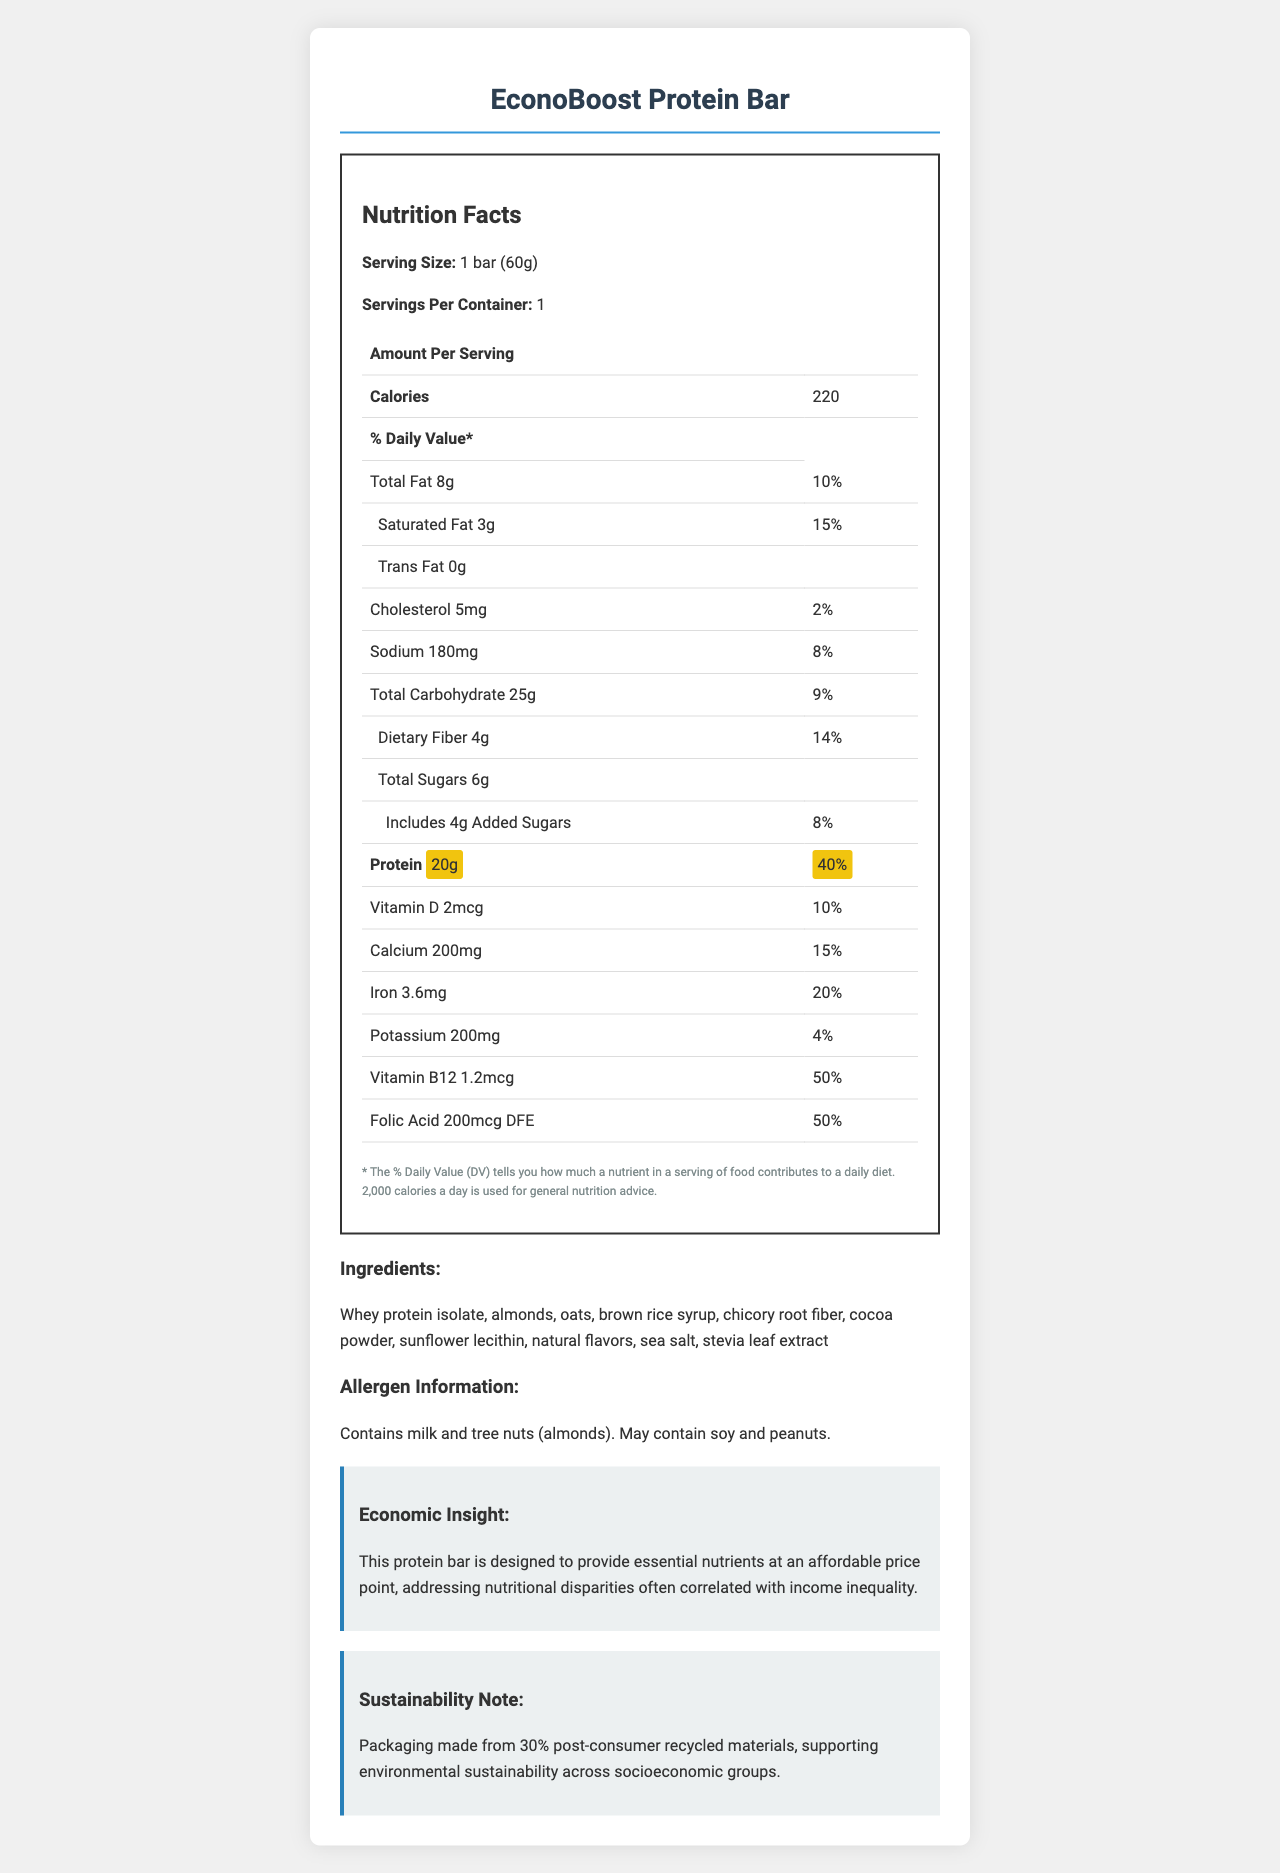what is the serving size? The serving size is explicitly mentioned under the Nutrition Facts section.
Answer: 1 bar (60g) How much protein does one serving of the EconoBoost Protein Bar contain? The amount of protein is highlighted and mentioned as 20g in the Nutrition Facts table.
Answer: 20g What percentage of the daily value of protein does the EconoBoost Protein Bar provide? Under the Nutrition Facts, the protein content is indicated as 20g, which corresponds to 40% of the daily value.
Answer: 40% Which vitamins and minerals are highlighted in the nutrition label? The vitamins and minerals, along with their amounts and daily values, are listed in the Nutrition Facts table.
Answer: Vitamin D, Calcium, Iron, Potassium, Vitamin B12, Folic Acid How much calcium is in one serving of the EconoBoost Protein Bar? In the Nutrition Facts, the calcium content is specified as 200mg.
Answer: 200mg What is the total carbohydrate content per serving? The total carbohydrate content per serving is listed as 25g in the Nutrition Facts.
Answer: 25g How many grams of dietary fiber does the bar contain? The dietary fiber content is listed as 4g under total carbohydrates.
Answer: 4g What is the economic insight mentioned about the EconoBoost Protein Bar? A. The bar contains organic ingredients. B. The bar is designed to be affordable and nutritious. C. The bar has zero added sugars. D. The packaging is 100% biodegradable. The economic insight section mentions that the bar is designed to provide essential nutrients at an affordable price point.
Answer: B Which of the following allergens are present in the EconoBoost Protein Bar? A. Milk B. Almonds C. Peanuts D. Soy The allergen information specifies that the bar contains milk and tree nuts (almonds), and may contain soy and peanuts.
Answer: A, B Is the EconoBoost Protein Bar suitable for people with peanut allergies? According to the allergen information, the bar may contain peanuts, which suggests it is not suitable for people with peanut allergies.
Answer: No Summarize the main idea of the document. The document extensively details the nutritional content, serving size, and daily values for various nutrients in the EconoBoost Protein Bar. It also includes additional insights on the economic and environmental considerations of the product.
Answer: The main idea of the document is to provide detailed nutritional information about the EconoBoost Protein Bar, including its ingredients, allergens, and economic impact. It emphasizes the protein content and several key micronutrients, presenting the product as both nutritious and affordable. The document also highlights the bar's contribution to environmental sustainability through its packaging. What is the main ingredient in the protein bar? The ingredients list, prominently displayed, starts with whey protein isolate, indicating it is the main ingredient.
Answer: Whey protein isolate What is the purpose of using post-consumer recycled materials for the packaging? The sustainability note mentions that using packaging made from 30% post-consumer recycled materials supports environmental sustainability across different socioeconomic groups.
Answer: Supporting environmental sustainability across socioeconomic groups Which micronutrient is provided in the highest percentage of the daily value? A. Vitamin D B. Calcium C. Iron D. Vitamin B12 Vitamin B12 is provided at 50% of the daily value, the highest among the listed micronutrients.
Answer: D Is there any information provided on the cost of the protein bar? The document does not provide any specific details regarding the cost of the EconoBoost Protein Bar, only mentioning its affordability in general terms.
Answer: Not enough information How much saturated fat is in the EconoBoost Protein Bar? The Nutrition Facts table lists the saturated fat content as 3g.
Answer: 3g What makes the EconoBoost Protein Bar a potential choice to address nutritional disparities? The economic insight section mentions that the bar is designed to provide essential nutrients affordably, addressing nutritional disparities often correlated with income inequality.
Answer: Its provision of essential nutrients at an affordable price point Which ingredient in the protein bar is responsible for its sweetness? The ingredient stevia leaf extract is included in the ingredients list and is known for its sweetness.
Answer: Stevia leaf extract What is the daily value percentage for iron provided by the bar? The iron content is listed as 3.6mg, which is 20% of the daily value.
Answer: 20% How many grams of added sugars does the EconoBoost Protein Bar contain? The Nutrition Facts table states that there are 4g of added sugars in the bar.
Answer: 4g 